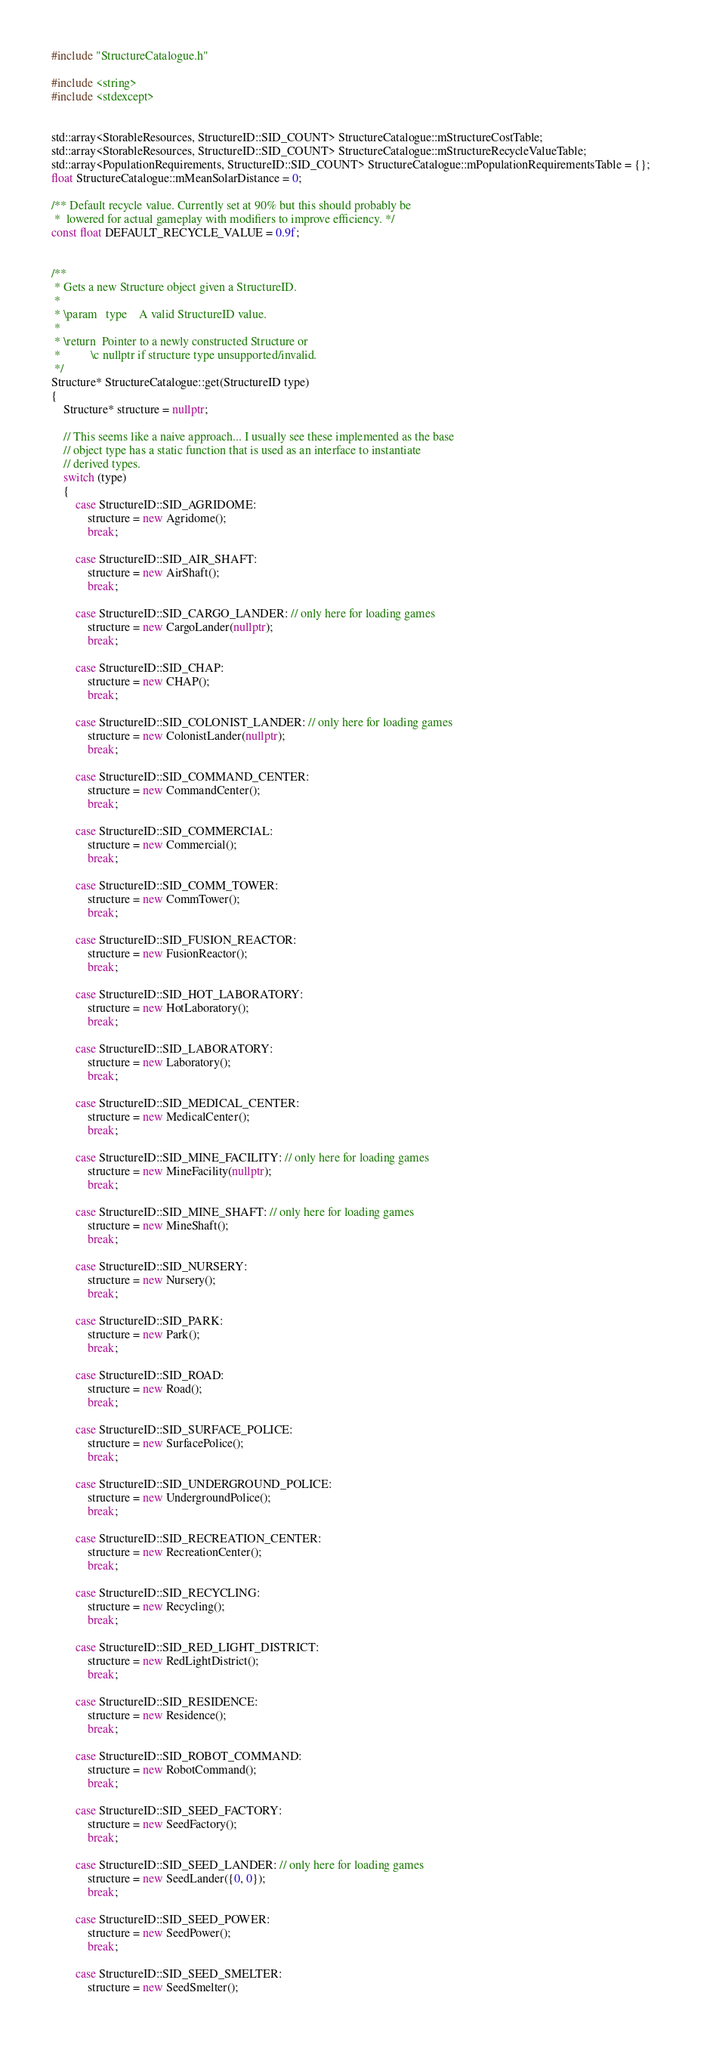Convert code to text. <code><loc_0><loc_0><loc_500><loc_500><_C++_>#include "StructureCatalogue.h"

#include <string>
#include <stdexcept>


std::array<StorableResources, StructureID::SID_COUNT> StructureCatalogue::mStructureCostTable;
std::array<StorableResources, StructureID::SID_COUNT> StructureCatalogue::mStructureRecycleValueTable;
std::array<PopulationRequirements, StructureID::SID_COUNT> StructureCatalogue::mPopulationRequirementsTable = {};
float StructureCatalogue::mMeanSolarDistance = 0;

/**	Default recycle value. Currently set at 90% but this should probably be
 *	lowered for actual gameplay with modifiers to improve efficiency. */
const float DEFAULT_RECYCLE_VALUE = 0.9f;


/**
 * Gets a new Structure object given a StructureID.
 * 
 * \param	type	A valid StructureID value.
 * 
 * \return	Pointer to a newly constructed Structure or
 *			\c nullptr if structure type unsupported/invalid.
 */
Structure* StructureCatalogue::get(StructureID type)
{
	Structure* structure = nullptr;

	// This seems like a naive approach... I usually see these implemented as the base
	// object type has a static function that is used as an interface to instantiate
	// derived types.
	switch (type)
	{
		case StructureID::SID_AGRIDOME:
			structure = new Agridome();
			break;

		case StructureID::SID_AIR_SHAFT:
			structure = new AirShaft();
			break;

		case StructureID::SID_CARGO_LANDER: // only here for loading games
			structure = new CargoLander(nullptr);
			break;

		case StructureID::SID_CHAP:
			structure = new CHAP();
			break;

		case StructureID::SID_COLONIST_LANDER: // only here for loading games
			structure = new ColonistLander(nullptr);
			break;

		case StructureID::SID_COMMAND_CENTER:
			structure = new CommandCenter();
			break;

		case StructureID::SID_COMMERCIAL:
			structure = new Commercial();
			break;

		case StructureID::SID_COMM_TOWER:
			structure = new CommTower();
			break;

		case StructureID::SID_FUSION_REACTOR:
			structure = new FusionReactor();
			break;

		case StructureID::SID_HOT_LABORATORY:
			structure = new HotLaboratory();
			break;

		case StructureID::SID_LABORATORY:
			structure = new Laboratory();
			break;

		case StructureID::SID_MEDICAL_CENTER:
			structure = new MedicalCenter();
			break;

		case StructureID::SID_MINE_FACILITY: // only here for loading games
			structure = new MineFacility(nullptr);
			break;

		case StructureID::SID_MINE_SHAFT: // only here for loading games
			structure = new MineShaft();
			break;

		case StructureID::SID_NURSERY:
			structure = new Nursery();
			break;

		case StructureID::SID_PARK:
			structure = new Park();
			break;

		case StructureID::SID_ROAD:
			structure = new Road();
			break;

		case StructureID::SID_SURFACE_POLICE:
			structure = new SurfacePolice();
			break;

		case StructureID::SID_UNDERGROUND_POLICE:
			structure = new UndergroundPolice();
			break;

		case StructureID::SID_RECREATION_CENTER:
			structure = new RecreationCenter();
			break;

		case StructureID::SID_RECYCLING:
			structure = new Recycling();
			break;

		case StructureID::SID_RED_LIGHT_DISTRICT:
			structure = new RedLightDistrict();
			break;

		case StructureID::SID_RESIDENCE:
			structure = new Residence();
			break;

		case StructureID::SID_ROBOT_COMMAND:
			structure = new RobotCommand();
			break;

		case StructureID::SID_SEED_FACTORY:
			structure = new SeedFactory();
			break;

		case StructureID::SID_SEED_LANDER: // only here for loading games
			structure = new SeedLander({0, 0});
			break;

		case StructureID::SID_SEED_POWER:
			structure = new SeedPower();
			break;

		case StructureID::SID_SEED_SMELTER:
			structure = new SeedSmelter();</code> 